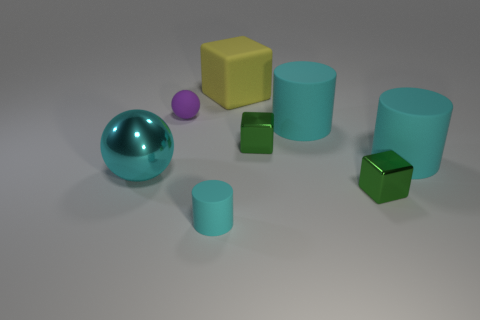Add 2 red metal cylinders. How many objects exist? 10 Subtract all balls. How many objects are left? 6 Subtract all small shiny objects. Subtract all tiny purple matte things. How many objects are left? 5 Add 3 big matte cylinders. How many big matte cylinders are left? 5 Add 5 tiny things. How many tiny things exist? 9 Subtract 0 green balls. How many objects are left? 8 